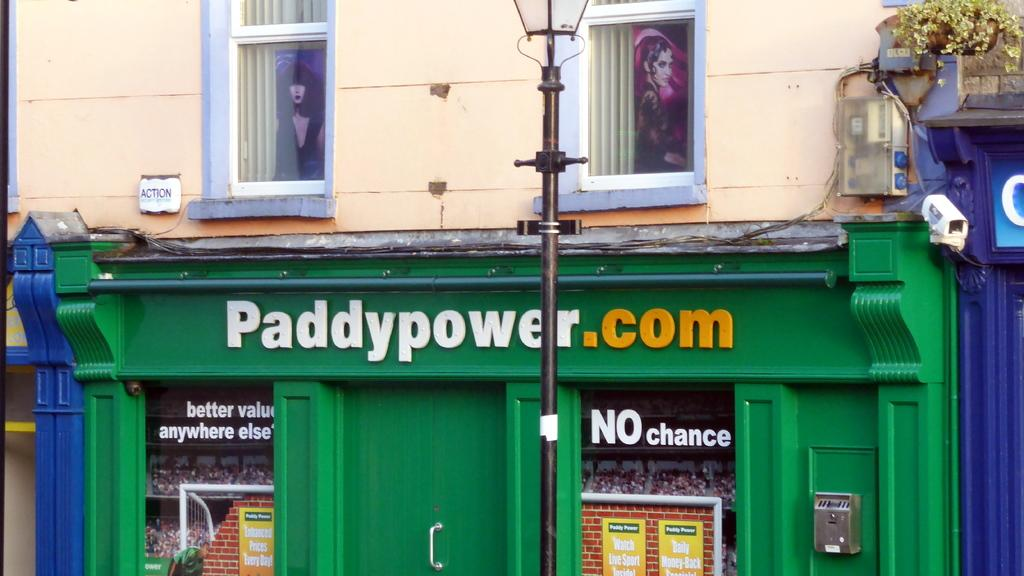What type of structure is visible in the image? There is a building in the image. What are some of the features of the building? The building has walls, windows, curtains, posters, a pole, wires, a plant, and a door. Can you describe the objects present in the image? There are a few objects in the image, but their specific nature is not mentioned in the provided facts. What lesson is the ladybug teaching in the image? There is no ladybug present in the image, so it is not possible to answer that question. 